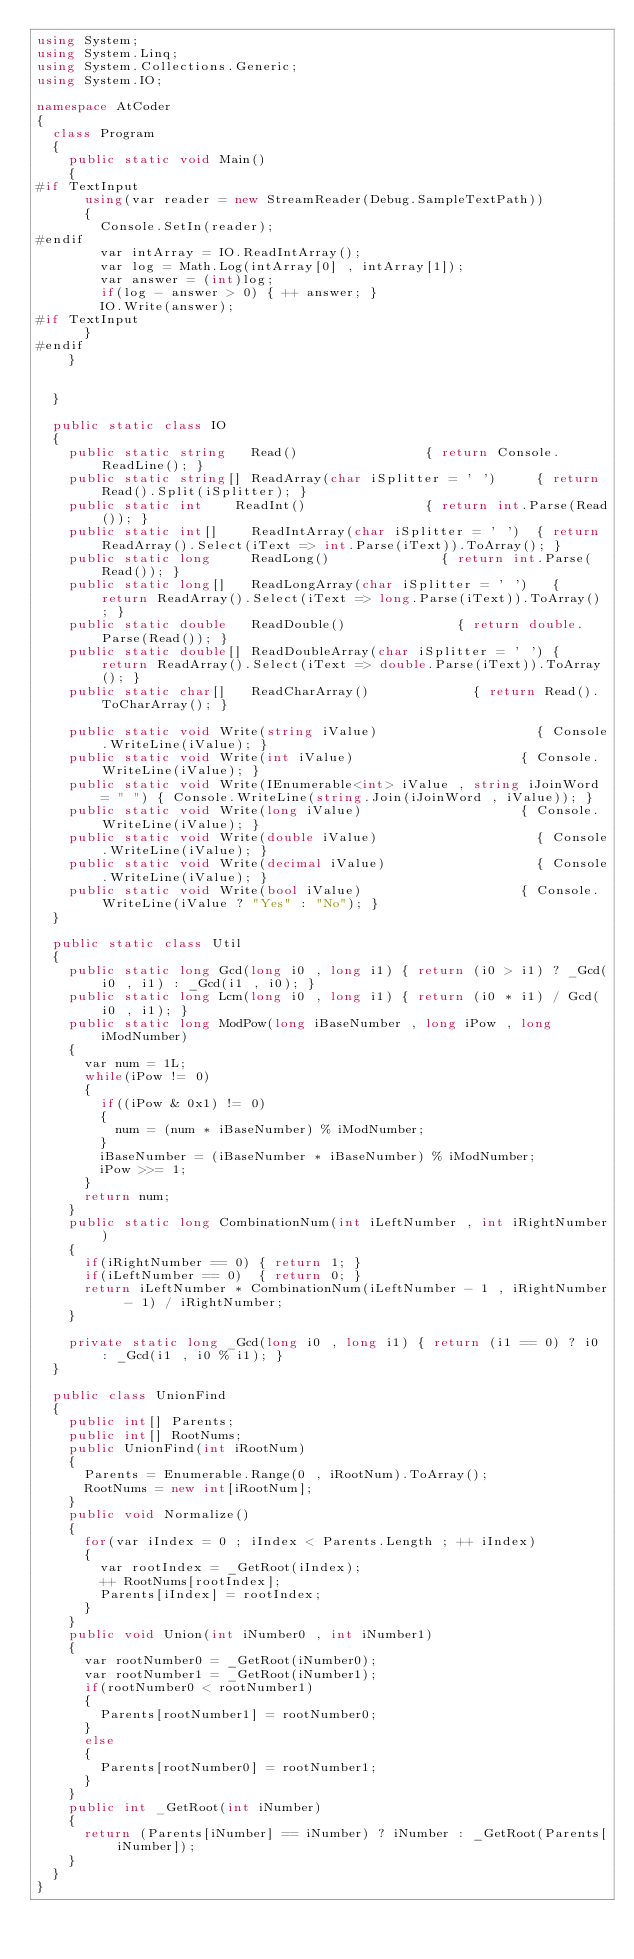<code> <loc_0><loc_0><loc_500><loc_500><_C#_>using System;
using System.Linq;
using System.Collections.Generic;
using System.IO;

namespace AtCoder
{
	class Program
	{
		public static void Main()
		{
#if TextInput
			using(var reader = new StreamReader(Debug.SampleTextPath)) 
			{
				Console.SetIn(reader);
#endif
				var intArray = IO.ReadIntArray();
				var log = Math.Log(intArray[0] , intArray[1]);
				var answer = (int)log;
				if(log - answer > 0) { ++ answer; }
				IO.Write(answer);
#if TextInput
			}
#endif
		}

		
	}

	public static class IO
	{
		public static string   Read()								 { return Console.ReadLine(); }
		public static string[] ReadArray(char iSplitter = ' ')		 { return Read().Split(iSplitter); }
		public static int	   ReadInt()							 { return int.Parse(Read()); }
		public static int[]	   ReadIntArray(char iSplitter = ' ')	 { return ReadArray().Select(iText => int.Parse(iText)).ToArray(); }
		public static long	   ReadLong()							 { return int.Parse(Read()); }
		public static long[]   ReadLongArray(char iSplitter = ' ')	 { return ReadArray().Select(iText => long.Parse(iText)).ToArray(); }
		public static double   ReadDouble()							 { return double.Parse(Read()); }
		public static double[] ReadDoubleArray(char iSplitter = ' ') { return ReadArray().Select(iText => double.Parse(iText)).ToArray(); }
		public static char[]   ReadCharArray()						 { return Read().ToCharArray(); }

		public static void Write(string iValue)									   { Console.WriteLine(iValue); }
		public static void Write(int iValue)									   { Console.WriteLine(iValue); }
		public static void Write(IEnumerable<int> iValue , string iJoinWord = " ") { Console.WriteLine(string.Join(iJoinWord , iValue)); }
		public static void Write(long iValue)									   { Console.WriteLine(iValue); }
		public static void Write(double iValue)									   { Console.WriteLine(iValue); }
		public static void Write(decimal iValue)								   { Console.WriteLine(iValue); }
		public static void Write(bool iValue)									   { Console.WriteLine(iValue ? "Yes" : "No"); }
	}

	public static class Util
	{
		public static long Gcd(long i0 , long i1) { return (i0 > i1) ? _Gcd(i0 , i1) : _Gcd(i1 , i0); }
		public static long Lcm(long i0 , long i1) { return (i0 * i1) / Gcd(i0 , i1); }
		public static long ModPow(long iBaseNumber , long iPow , long iModNumber)
		{
			var num = 1L;
			while(iPow != 0)
			{
				if((iPow & 0x1) != 0)
				{
					num = (num * iBaseNumber) % iModNumber;
				}
				iBaseNumber = (iBaseNumber * iBaseNumber) % iModNumber;
				iPow >>= 1;
			}
			return num;
		}
		public static long CombinationNum(int iLeftNumber , int iRightNumber)
		{
			if(iRightNumber == 0) { return 1; }
			if(iLeftNumber == 0)  { return 0; }
			return iLeftNumber * CombinationNum(iLeftNumber - 1 , iRightNumber - 1) / iRightNumber;
		}

		private static long _Gcd(long i0 , long i1)	{ return (i1 == 0) ? i0 : _Gcd(i1 , i0 % i1); }
	}

	public class UnionFind
	{
		public int[] Parents;
		public int[] RootNums;
		public UnionFind(int iRootNum)
		{
			Parents = Enumerable.Range(0 , iRootNum).ToArray();
			RootNums = new int[iRootNum];
		}
		public void Normalize()
		{
			for(var iIndex = 0 ; iIndex < Parents.Length ; ++ iIndex)
			{
				var rootIndex = _GetRoot(iIndex);
				++ RootNums[rootIndex];
				Parents[iIndex] = rootIndex;
			}
		}
		public void Union(int iNumber0 , int iNumber1)
		{
			var rootNumber0 = _GetRoot(iNumber0);
			var rootNumber1 = _GetRoot(iNumber1);
			if(rootNumber0 < rootNumber1)
			{
				Parents[rootNumber1] = rootNumber0;
			}
			else
			{
				Parents[rootNumber0] = rootNumber1;
			}
		}
		public int _GetRoot(int iNumber)
		{
			return (Parents[iNumber] == iNumber) ? iNumber : _GetRoot(Parents[iNumber]);
		}
	}
}
</code> 